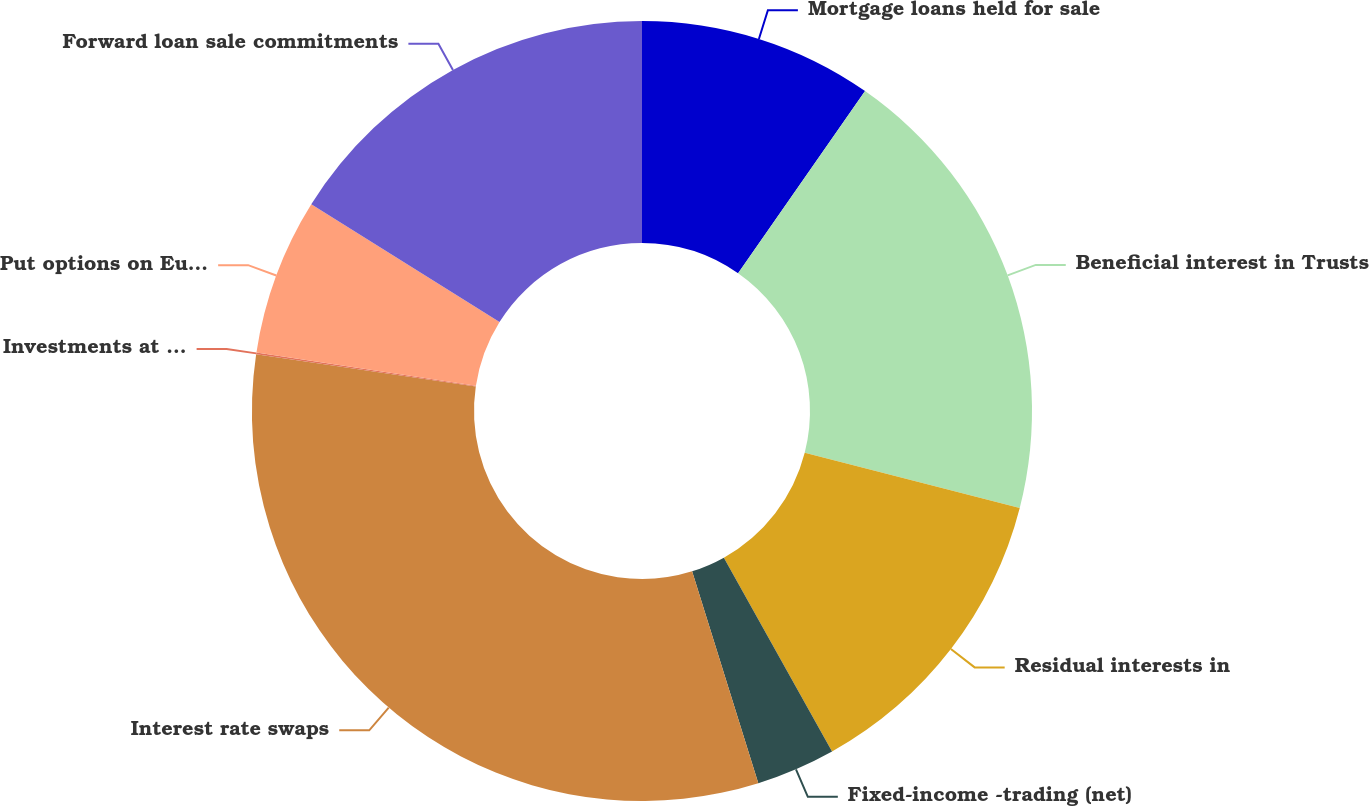<chart> <loc_0><loc_0><loc_500><loc_500><pie_chart><fcel>Mortgage loans held for sale<fcel>Beneficial interest in Trusts<fcel>Residual interests in<fcel>Fixed-income -trading (net)<fcel>Interest rate swaps<fcel>Investments at captive<fcel>Put options on Eurodollar<fcel>Forward loan sale commitments<nl><fcel>9.69%<fcel>19.31%<fcel>12.9%<fcel>3.28%<fcel>32.14%<fcel>0.08%<fcel>6.49%<fcel>16.11%<nl></chart> 